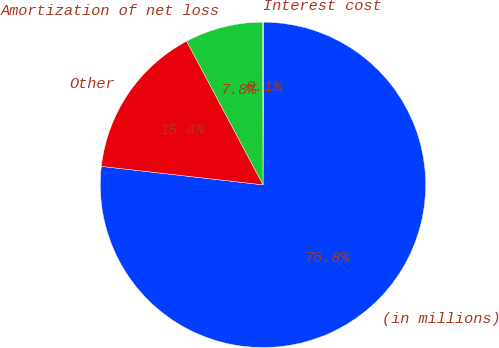Convert chart to OTSL. <chart><loc_0><loc_0><loc_500><loc_500><pie_chart><fcel>(in millions)<fcel>Interest cost<fcel>Amortization of net loss<fcel>Other<nl><fcel>76.76%<fcel>0.08%<fcel>7.75%<fcel>15.41%<nl></chart> 